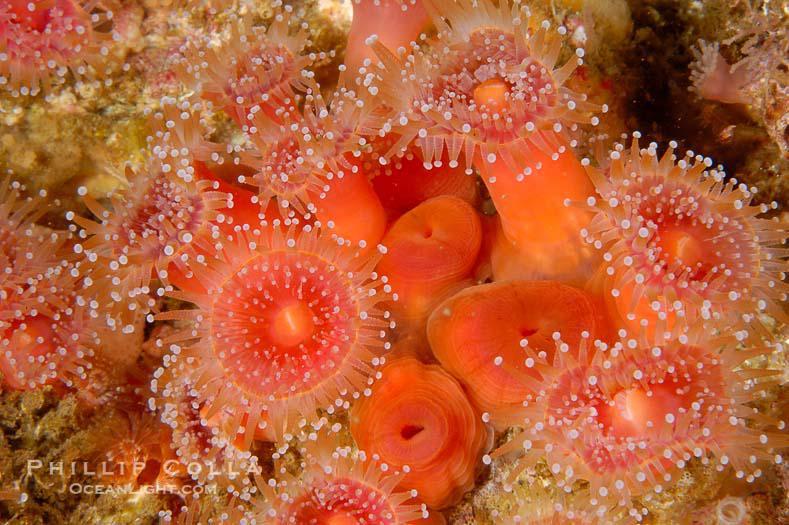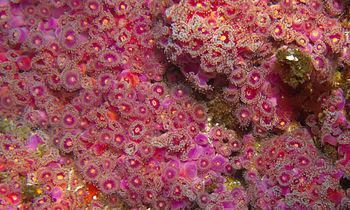The first image is the image on the left, the second image is the image on the right. Assess this claim about the two images: "In the image to the left, the creature clearly has a green tint to it.". Correct or not? Answer yes or no. No. The first image is the image on the left, the second image is the image on the right. Analyze the images presented: Is the assertion "One image shows a mass of violet-colored anemones, and the other image shows a mass of anemone with orangish-coral color and visible white dots at the end of each tendril." valid? Answer yes or no. Yes. 